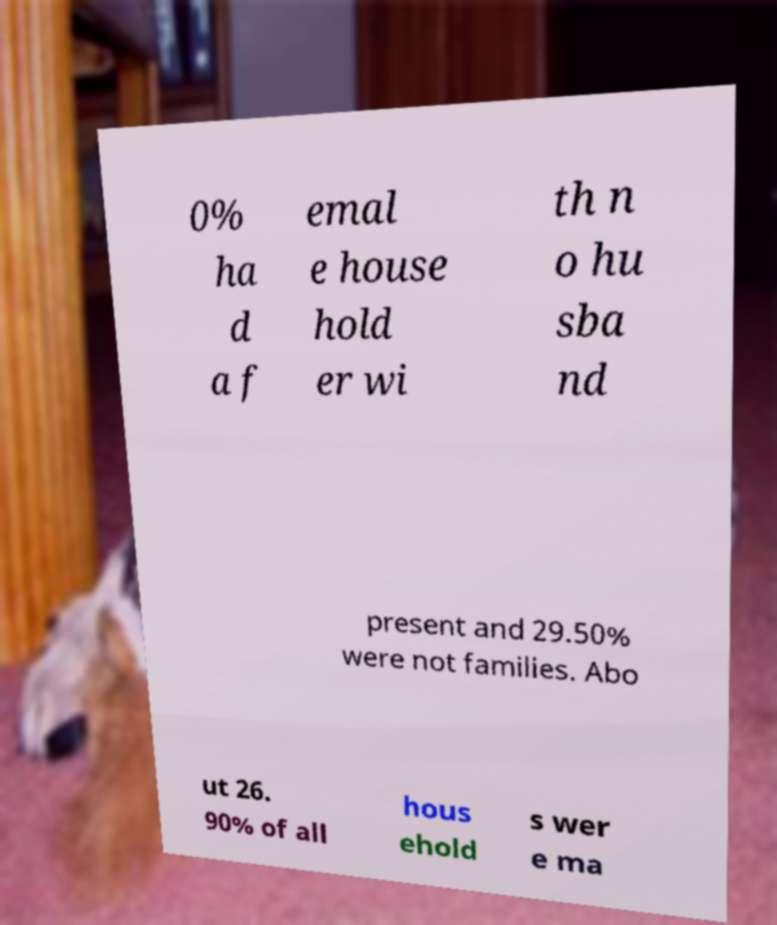Can you read and provide the text displayed in the image?This photo seems to have some interesting text. Can you extract and type it out for me? 0% ha d a f emal e house hold er wi th n o hu sba nd present and 29.50% were not families. Abo ut 26. 90% of all hous ehold s wer e ma 